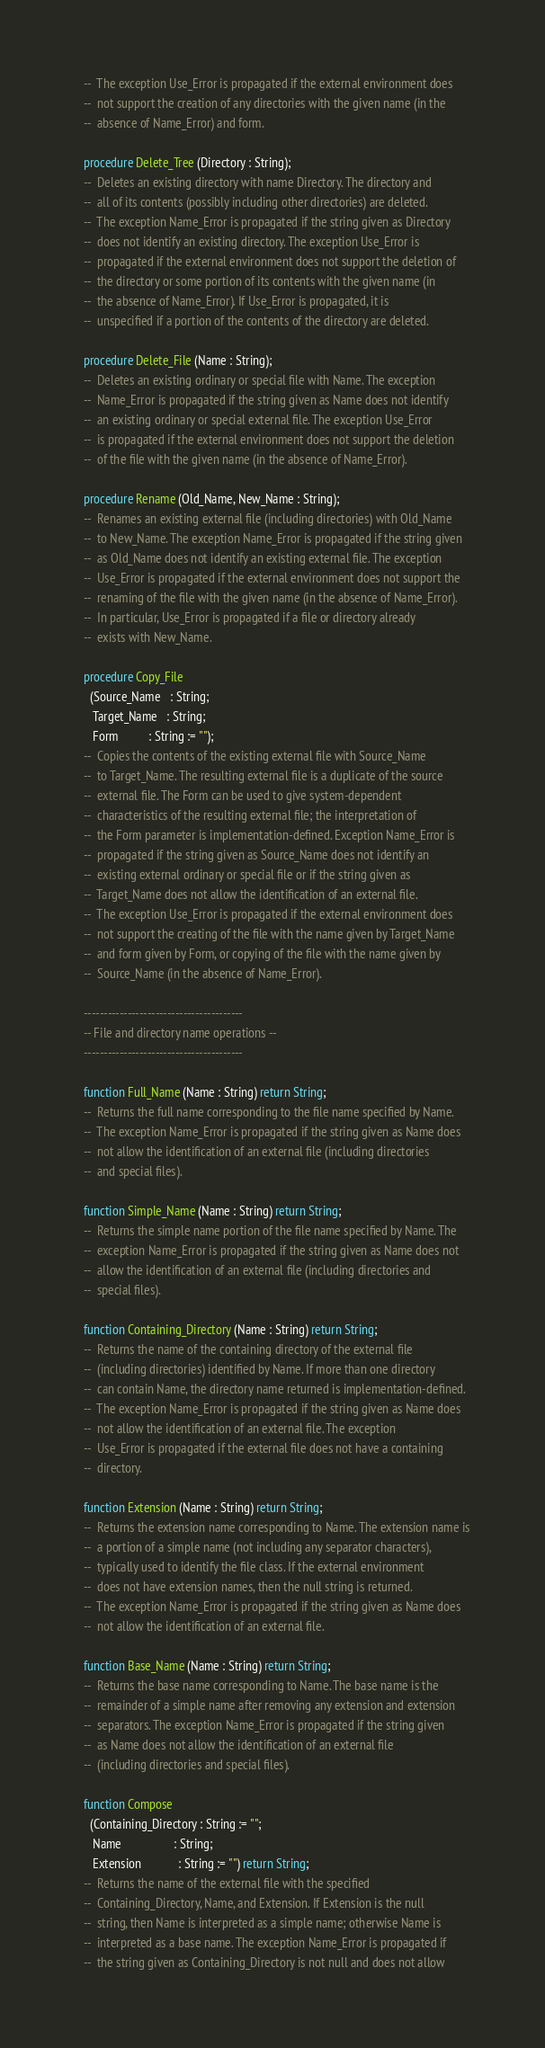<code> <loc_0><loc_0><loc_500><loc_500><_Ada_>   --  The exception Use_Error is propagated if the external environment does
   --  not support the creation of any directories with the given name (in the
   --  absence of Name_Error) and form.

   procedure Delete_Tree (Directory : String);
   --  Deletes an existing directory with name Directory. The directory and
   --  all of its contents (possibly including other directories) are deleted.
   --  The exception Name_Error is propagated if the string given as Directory
   --  does not identify an existing directory. The exception Use_Error is
   --  propagated if the external environment does not support the deletion of
   --  the directory or some portion of its contents with the given name (in
   --  the absence of Name_Error). If Use_Error is propagated, it is
   --  unspecified if a portion of the contents of the directory are deleted.

   procedure Delete_File (Name : String);
   --  Deletes an existing ordinary or special file with Name. The exception
   --  Name_Error is propagated if the string given as Name does not identify
   --  an existing ordinary or special external file. The exception Use_Error
   --  is propagated if the external environment does not support the deletion
   --  of the file with the given name (in the absence of Name_Error).

   procedure Rename (Old_Name, New_Name : String);
   --  Renames an existing external file (including directories) with Old_Name
   --  to New_Name. The exception Name_Error is propagated if the string given
   --  as Old_Name does not identify an existing external file. The exception
   --  Use_Error is propagated if the external environment does not support the
   --  renaming of the file with the given name (in the absence of Name_Error).
   --  In particular, Use_Error is propagated if a file or directory already
   --  exists with New_Name.

   procedure Copy_File
     (Source_Name   : String;
      Target_Name   : String;
      Form          : String := "");
   --  Copies the contents of the existing external file with Source_Name
   --  to Target_Name. The resulting external file is a duplicate of the source
   --  external file. The Form can be used to give system-dependent
   --  characteristics of the resulting external file; the interpretation of
   --  the Form parameter is implementation-defined. Exception Name_Error is
   --  propagated if the string given as Source_Name does not identify an
   --  existing external ordinary or special file or if the string given as
   --  Target_Name does not allow the identification of an external file.
   --  The exception Use_Error is propagated if the external environment does
   --  not support the creating of the file with the name given by Target_Name
   --  and form given by Form, or copying of the file with the name given by
   --  Source_Name (in the absence of Name_Error).

   ----------------------------------------
   -- File and directory name operations --
   ----------------------------------------

   function Full_Name (Name : String) return String;
   --  Returns the full name corresponding to the file name specified by Name.
   --  The exception Name_Error is propagated if the string given as Name does
   --  not allow the identification of an external file (including directories
   --  and special files).

   function Simple_Name (Name : String) return String;
   --  Returns the simple name portion of the file name specified by Name. The
   --  exception Name_Error is propagated if the string given as Name does not
   --  allow the identification of an external file (including directories and
   --  special files).

   function Containing_Directory (Name : String) return String;
   --  Returns the name of the containing directory of the external file
   --  (including directories) identified by Name. If more than one directory
   --  can contain Name, the directory name returned is implementation-defined.
   --  The exception Name_Error is propagated if the string given as Name does
   --  not allow the identification of an external file. The exception
   --  Use_Error is propagated if the external file does not have a containing
   --  directory.

   function Extension (Name : String) return String;
   --  Returns the extension name corresponding to Name. The extension name is
   --  a portion of a simple name (not including any separator characters),
   --  typically used to identify the file class. If the external environment
   --  does not have extension names, then the null string is returned.
   --  The exception Name_Error is propagated if the string given as Name does
   --  not allow the identification of an external file.

   function Base_Name (Name : String) return String;
   --  Returns the base name corresponding to Name. The base name is the
   --  remainder of a simple name after removing any extension and extension
   --  separators. The exception Name_Error is propagated if the string given
   --  as Name does not allow the identification of an external file
   --  (including directories and special files).

   function Compose
     (Containing_Directory : String := "";
      Name                 : String;
      Extension            : String := "") return String;
   --  Returns the name of the external file with the specified
   --  Containing_Directory, Name, and Extension. If Extension is the null
   --  string, then Name is interpreted as a simple name; otherwise Name is
   --  interpreted as a base name. The exception Name_Error is propagated if
   --  the string given as Containing_Directory is not null and does not allow</code> 